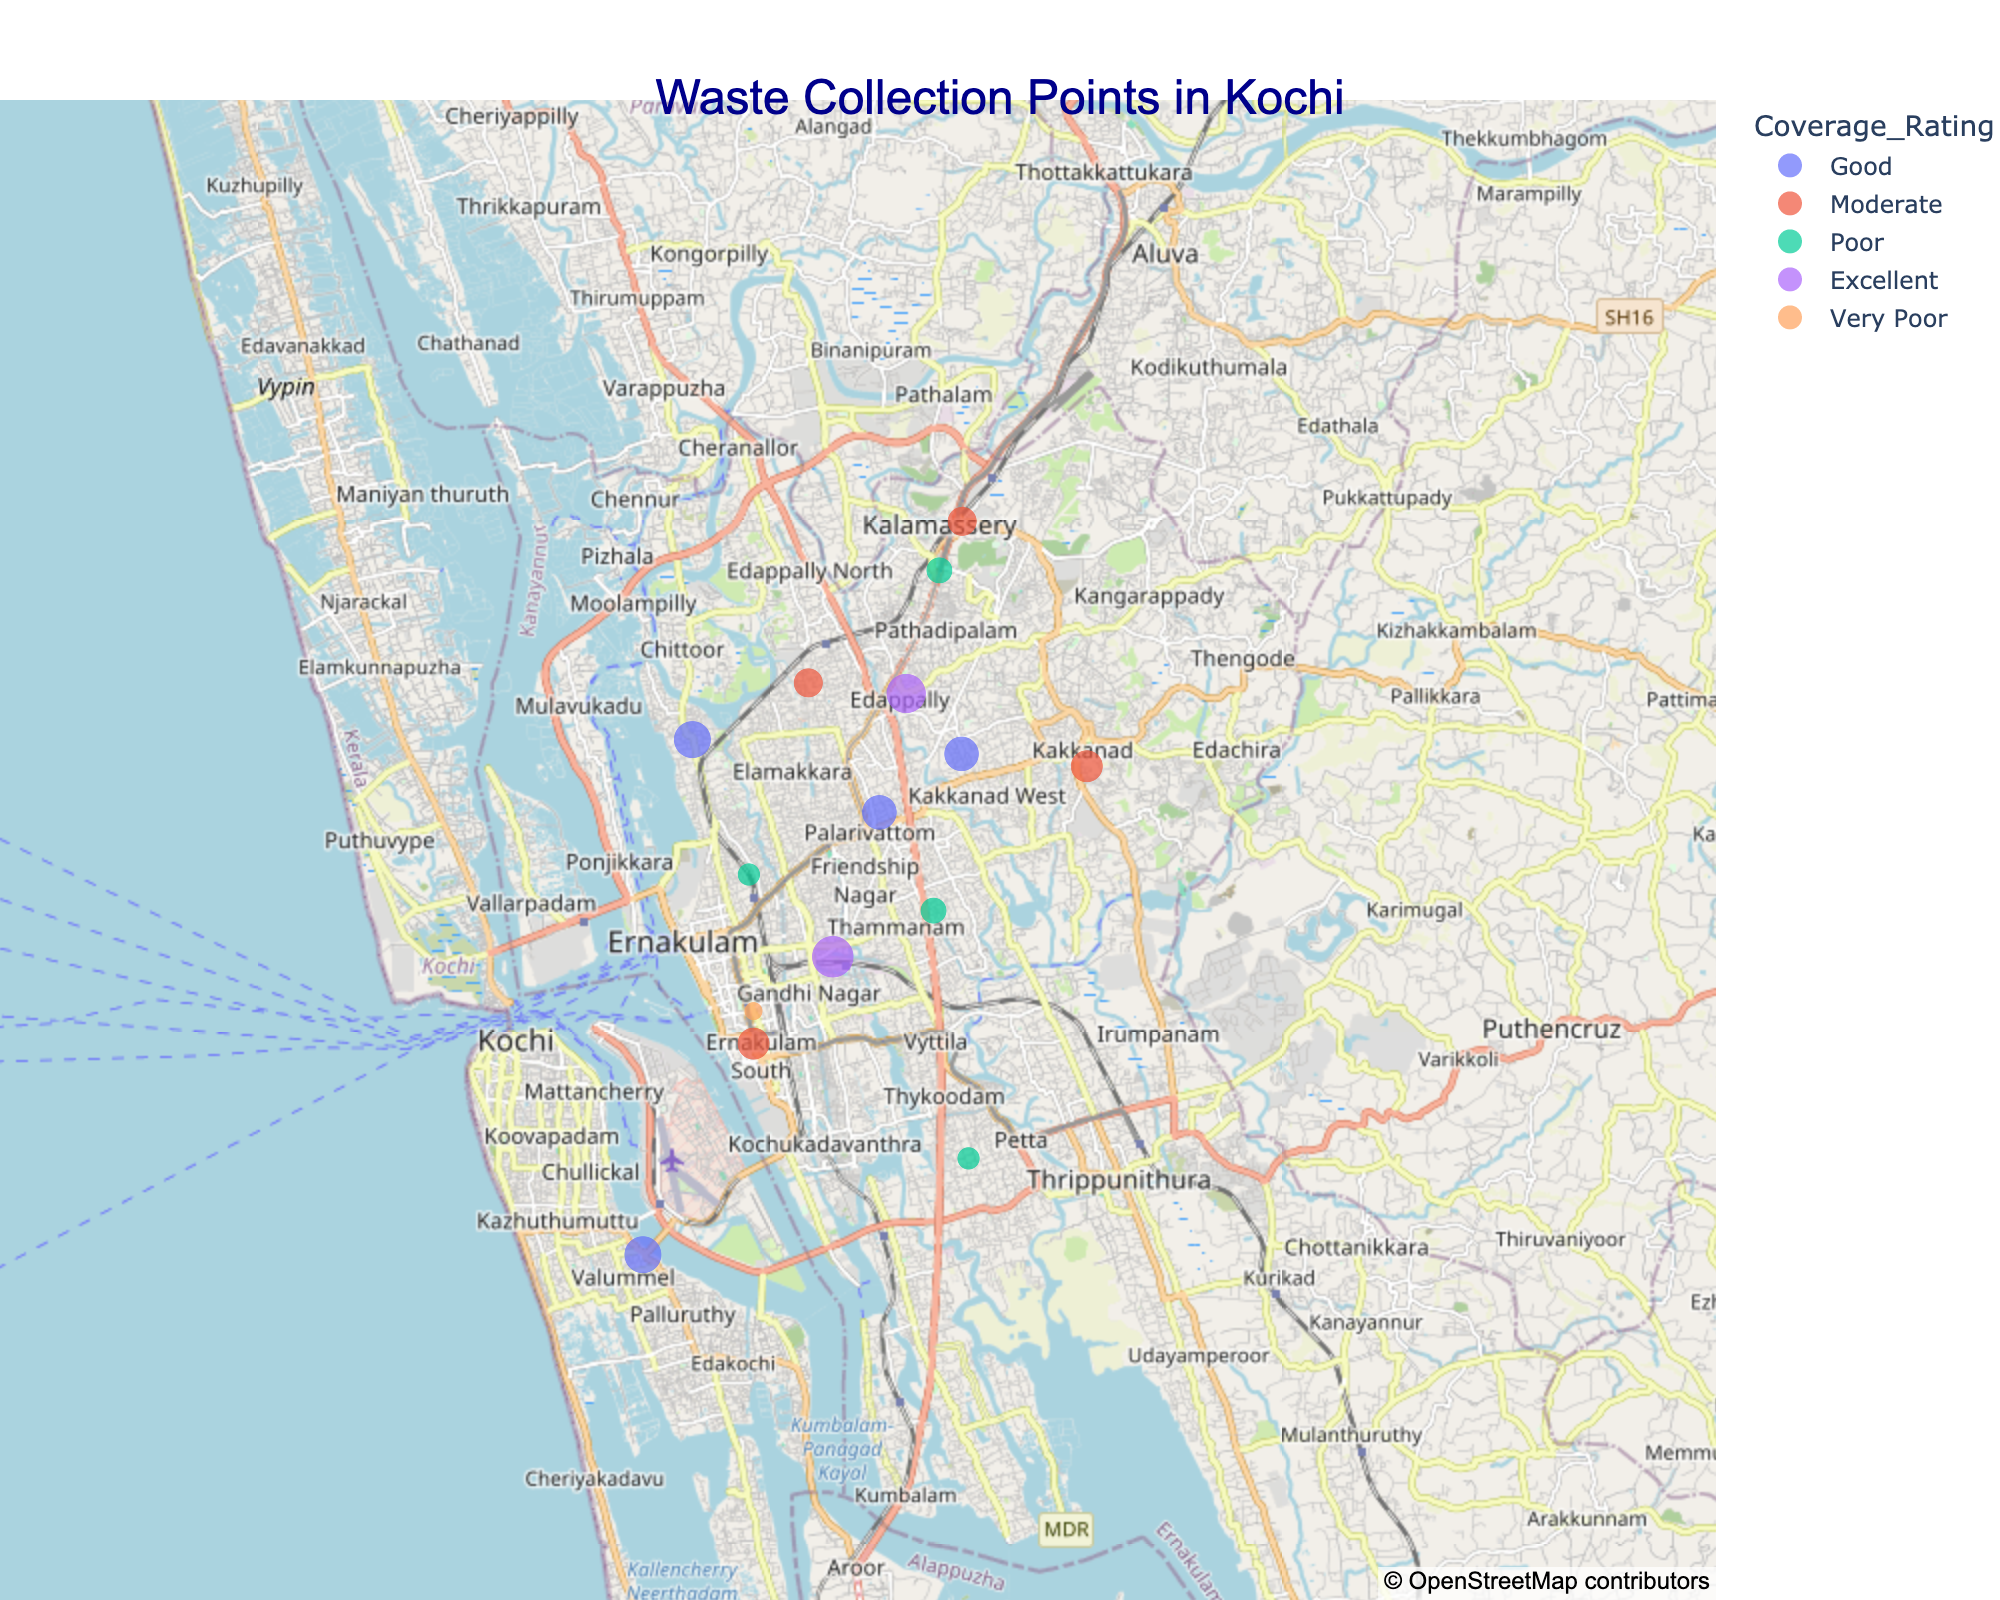Which area in Kochi has the highest number of waste collection points? The figure shows the size of the plots corresponding to the number of collection points. The largest circle is in Kochi City with 10 collection points.
Answer: Kochi City Which area has the lowest collection coverage rating? The color-coding in the plot represents the coverage rating. Willingdon Island, with a very small circle in dark red, indicates "Very Poor" coverage rating.
Answer: Willingdon Island How many areas in Kochi have a 'Poor' coverage rating? Areas with a "Poor" rating are colored in a darkish red on the plot. There are four such areas: Palluruthy, Vypeen, Pachalam, and Kumbalangi.
Answer: Four Which area has the most 'Excellent' coverage rating and what is its number of collection points? The "Excellent" coverage areas are colored in green on the plot. Edappally and Kochi City both have "Excellent" ratings. Because Kochi City has a larger circle (10 collection points) compared to Edappally (9 collection points), Kochi City has the most collection points with "Excellent" coverage.
Answer: Kochi City, 10 Are there more areas with 'Moderate' coverage rating or 'Good' coverage rating? By looking at the legend and finding moderate (yellow-orange) and good (light green) colored areas, we count three areas with 'Moderate' (Mattancherry, Kaloor, Kadavanthra, Elamakkara) and four areas with 'Good' (Fort Kochi, Thoppumpady, Panampilly Nagar, Marine Drive).
Answer: Good Which area needs urgent improvement in waste collection based on the figure? The area with "Very Poor" coverage rating that stands out the most is Willingdon Island with only 2 collection points, depicted as a small dark red circle.
Answer: Willingdon Island What is the difference between the number of collection points in Fort Kochi and Vypeen? According to the figure, Fort Kochi has 8 collection points and Vypeen has 3 collection points. The difference is therefore 8 - 3 = 5.
Answer: 5 What are the coordinates (latitude and longitude) of the area with the worst coverage rating? By referring to the geographic plot, the worst coverage rating is marked by a dark red circle, found on Willingdon Island. The coordinates for Willingdon Island in the data are (9.9724, 76.2863).
Answer: (9.9724, 76.2863) Is there a visible difference in the geographical spread of areas with 'Good' and 'Moderate' coverage ratings? By observing the colors and positions of the circles on the plot, areas with 'Good' (greenish) rating seem to be spread more evenly across Kochi compared to 'Moderate' (yellow-orange) rating, which appear to be more clustered.
Answer: Yes 